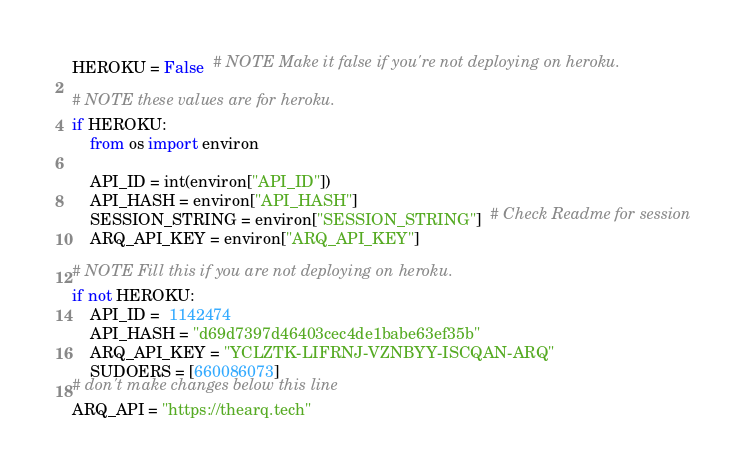Convert code to text. <code><loc_0><loc_0><loc_500><loc_500><_Python_>HEROKU = False  # NOTE Make it false if you're not deploying on heroku.

# NOTE these values are for heroku.
if HEROKU:
    from os import environ

    API_ID = int(environ["API_ID"])
    API_HASH = environ["API_HASH"]
    SESSION_STRING = environ["SESSION_STRING"]  # Check Readme for session
    ARQ_API_KEY = environ["ARQ_API_KEY"]

# NOTE Fill this if you are not deploying on heroku.
if not HEROKU:
    API_ID =  1142474
    API_HASH = "d69d7397d46403cec4de1babe63ef35b"
    ARQ_API_KEY = "YCLZTK-LIFRNJ-VZNBYY-ISCQAN-ARQ"
    SUDOERS = [660086073]
# don't make changes below this line
ARQ_API = "https://thearq.tech"
</code> 